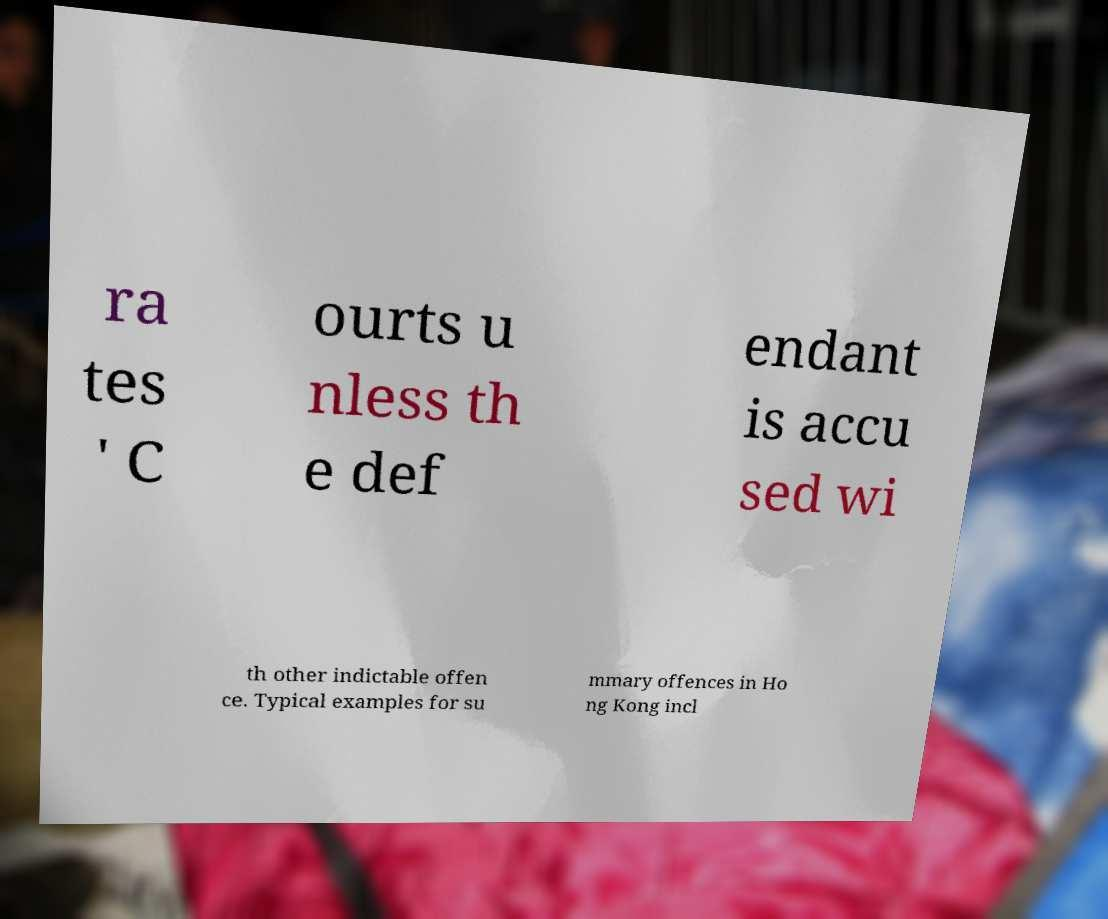Can you read and provide the text displayed in the image?This photo seems to have some interesting text. Can you extract and type it out for me? ra tes ' C ourts u nless th e def endant is accu sed wi th other indictable offen ce. Typical examples for su mmary offences in Ho ng Kong incl 